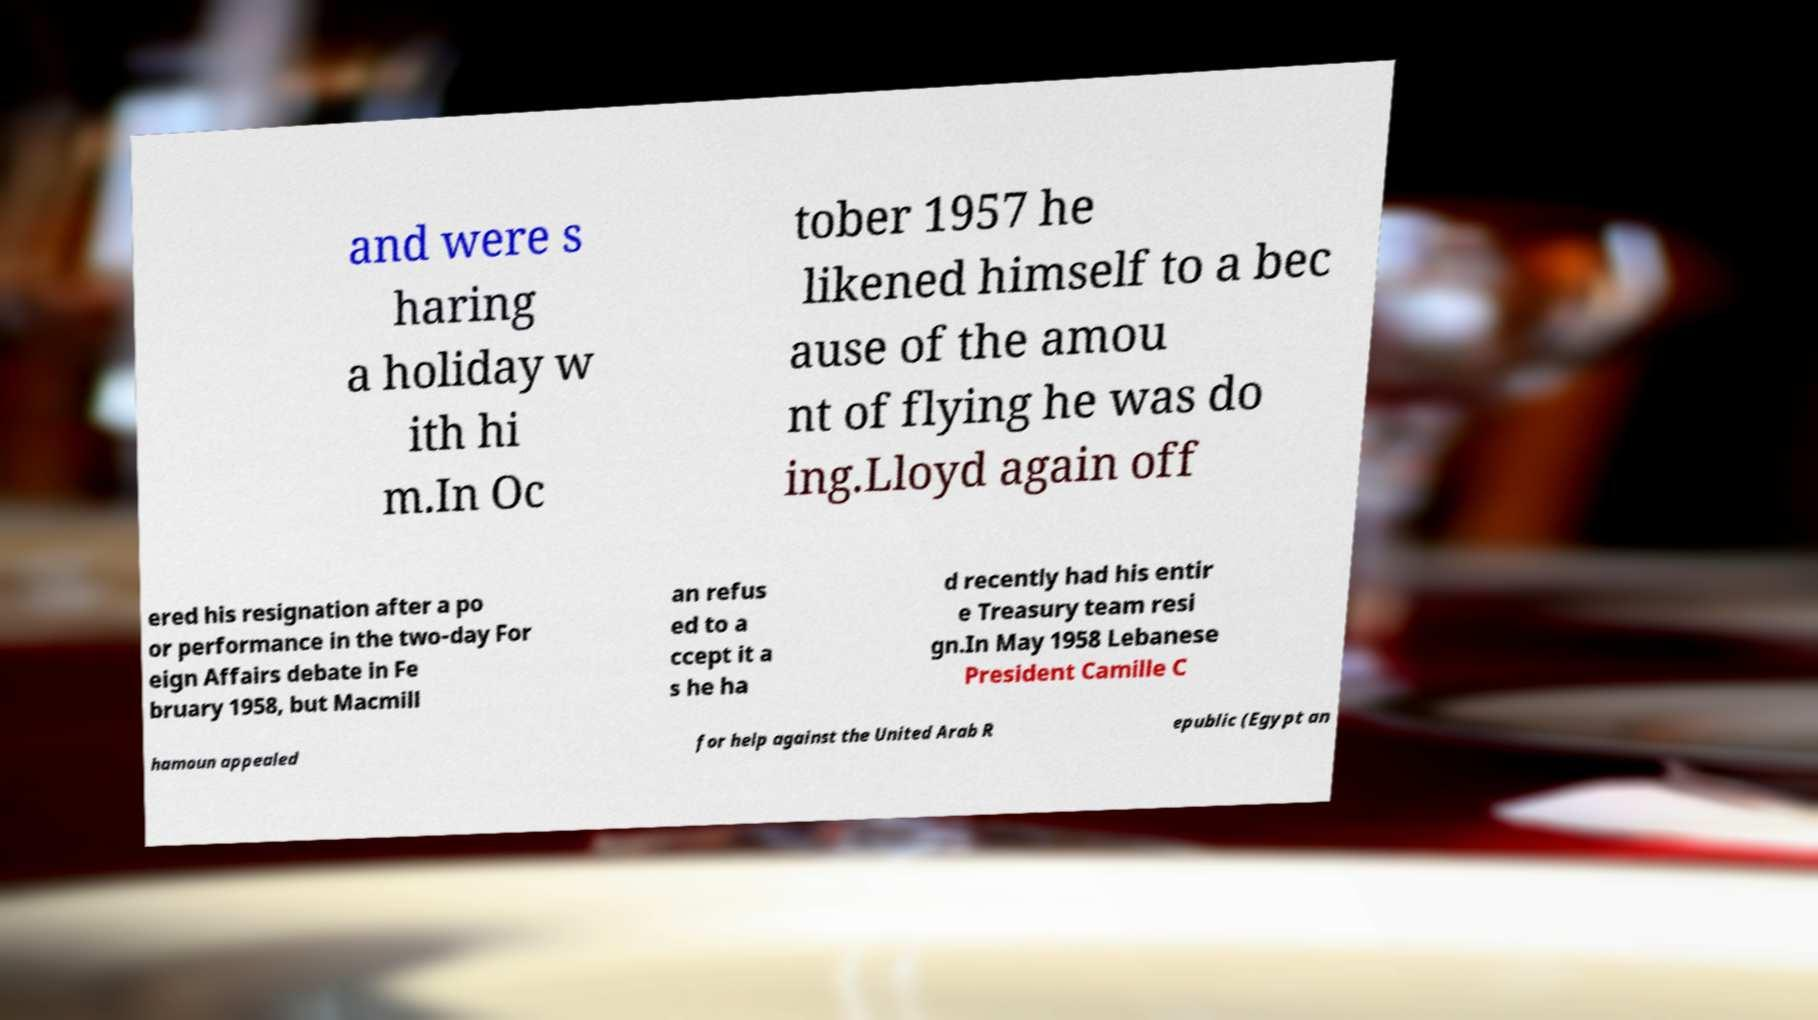Can you accurately transcribe the text from the provided image for me? and were s haring a holiday w ith hi m.In Oc tober 1957 he likened himself to a bec ause of the amou nt of flying he was do ing.Lloyd again off ered his resignation after a po or performance in the two-day For eign Affairs debate in Fe bruary 1958, but Macmill an refus ed to a ccept it a s he ha d recently had his entir e Treasury team resi gn.In May 1958 Lebanese President Camille C hamoun appealed for help against the United Arab R epublic (Egypt an 